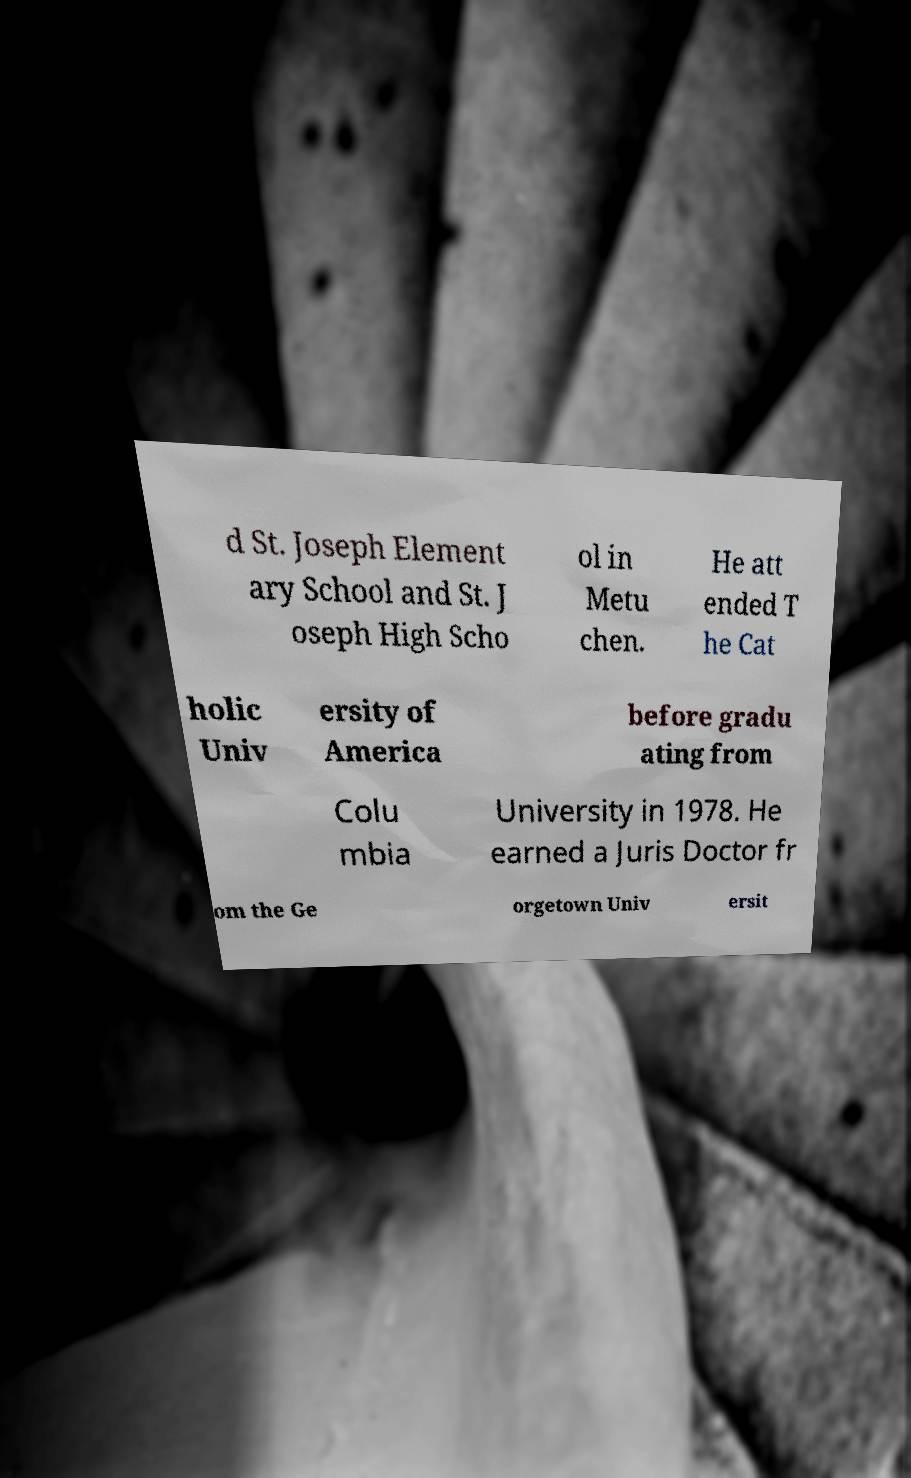What messages or text are displayed in this image? I need them in a readable, typed format. d St. Joseph Element ary School and St. J oseph High Scho ol in Metu chen. He att ended T he Cat holic Univ ersity of America before gradu ating from Colu mbia University in 1978. He earned a Juris Doctor fr om the Ge orgetown Univ ersit 